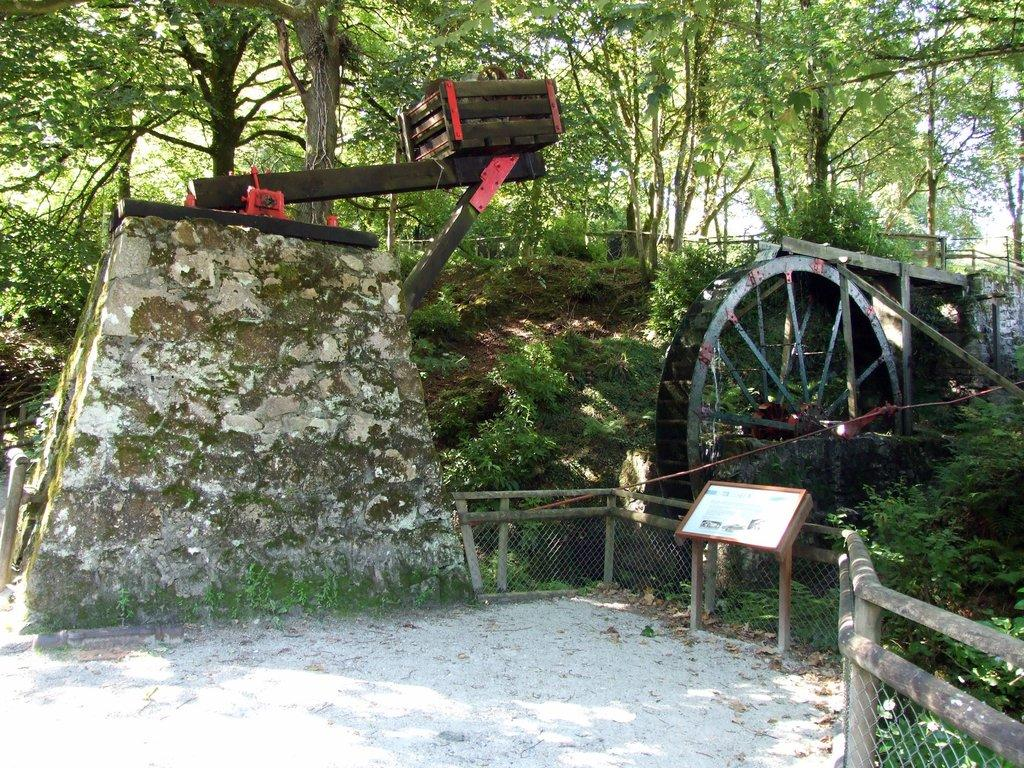What type of barrier can be seen in the image? There is a fence in the image. What object made of wood is present in the image? There is a wooden box in the image. What type of structure can be seen in the image? There is a wall in the image. What round object is visible in the image? There is a wheel in the image. What wooden object is present in the image? There is a wooden board in the image. What type of vegetation is present in the image? There are plants and trees in the image. How many corks are scattered on the ground in the image? There are no corks present in the image. What type of transportation can be seen in the image? There are no bikes or any other type of transportation present in the image. 